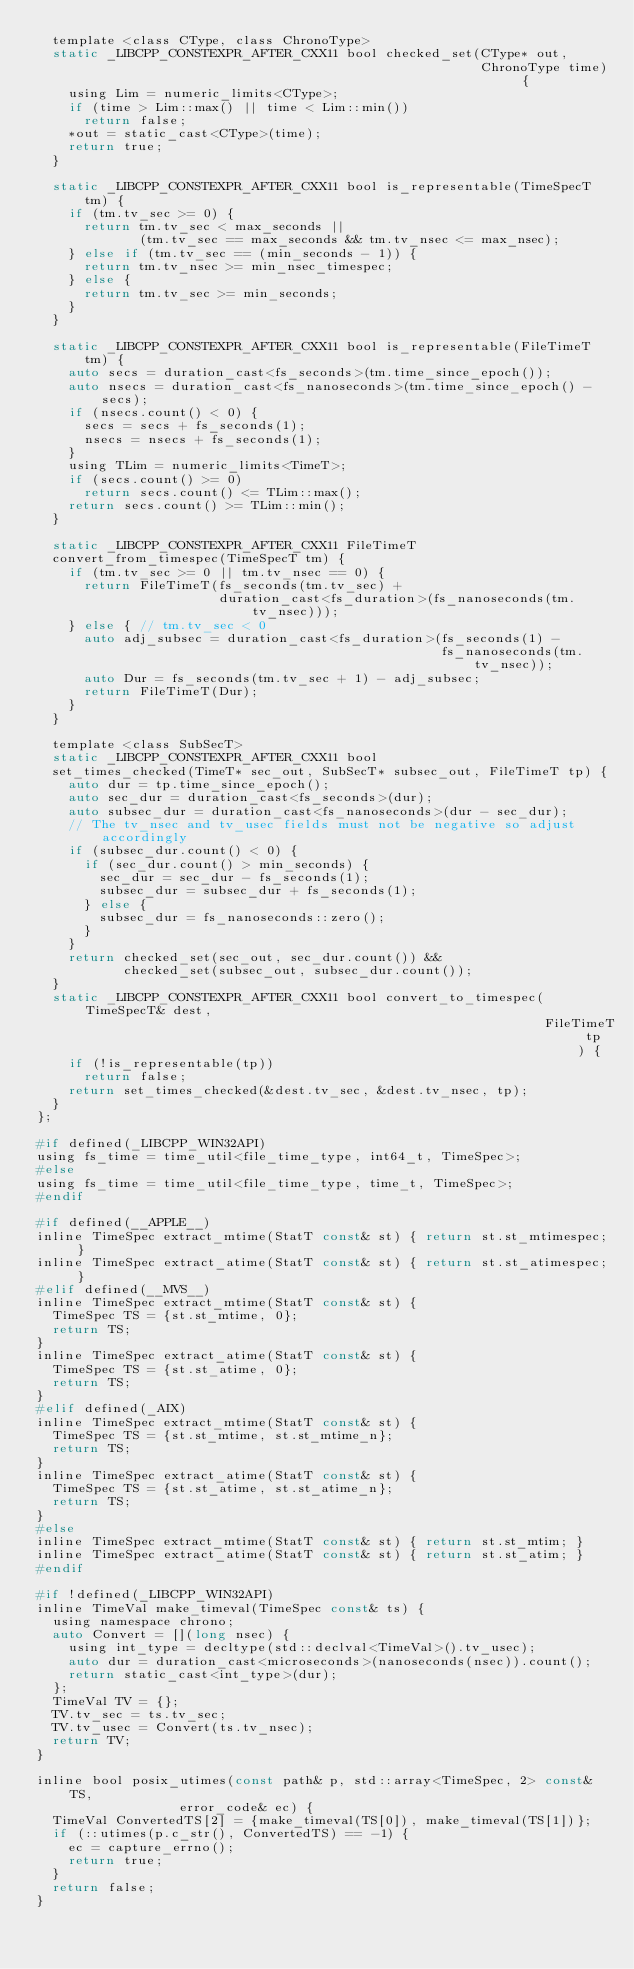Convert code to text. <code><loc_0><loc_0><loc_500><loc_500><_C_>  template <class CType, class ChronoType>
  static _LIBCPP_CONSTEXPR_AFTER_CXX11 bool checked_set(CType* out,
                                                        ChronoType time) {
    using Lim = numeric_limits<CType>;
    if (time > Lim::max() || time < Lim::min())
      return false;
    *out = static_cast<CType>(time);
    return true;
  }

  static _LIBCPP_CONSTEXPR_AFTER_CXX11 bool is_representable(TimeSpecT tm) {
    if (tm.tv_sec >= 0) {
      return tm.tv_sec < max_seconds ||
             (tm.tv_sec == max_seconds && tm.tv_nsec <= max_nsec);
    } else if (tm.tv_sec == (min_seconds - 1)) {
      return tm.tv_nsec >= min_nsec_timespec;
    } else {
      return tm.tv_sec >= min_seconds;
    }
  }

  static _LIBCPP_CONSTEXPR_AFTER_CXX11 bool is_representable(FileTimeT tm) {
    auto secs = duration_cast<fs_seconds>(tm.time_since_epoch());
    auto nsecs = duration_cast<fs_nanoseconds>(tm.time_since_epoch() - secs);
    if (nsecs.count() < 0) {
      secs = secs + fs_seconds(1);
      nsecs = nsecs + fs_seconds(1);
    }
    using TLim = numeric_limits<TimeT>;
    if (secs.count() >= 0)
      return secs.count() <= TLim::max();
    return secs.count() >= TLim::min();
  }

  static _LIBCPP_CONSTEXPR_AFTER_CXX11 FileTimeT
  convert_from_timespec(TimeSpecT tm) {
    if (tm.tv_sec >= 0 || tm.tv_nsec == 0) {
      return FileTimeT(fs_seconds(tm.tv_sec) +
                       duration_cast<fs_duration>(fs_nanoseconds(tm.tv_nsec)));
    } else { // tm.tv_sec < 0
      auto adj_subsec = duration_cast<fs_duration>(fs_seconds(1) -
                                                   fs_nanoseconds(tm.tv_nsec));
      auto Dur = fs_seconds(tm.tv_sec + 1) - adj_subsec;
      return FileTimeT(Dur);
    }
  }

  template <class SubSecT>
  static _LIBCPP_CONSTEXPR_AFTER_CXX11 bool
  set_times_checked(TimeT* sec_out, SubSecT* subsec_out, FileTimeT tp) {
    auto dur = tp.time_since_epoch();
    auto sec_dur = duration_cast<fs_seconds>(dur);
    auto subsec_dur = duration_cast<fs_nanoseconds>(dur - sec_dur);
    // The tv_nsec and tv_usec fields must not be negative so adjust accordingly
    if (subsec_dur.count() < 0) {
      if (sec_dur.count() > min_seconds) {
        sec_dur = sec_dur - fs_seconds(1);
        subsec_dur = subsec_dur + fs_seconds(1);
      } else {
        subsec_dur = fs_nanoseconds::zero();
      }
    }
    return checked_set(sec_out, sec_dur.count()) &&
           checked_set(subsec_out, subsec_dur.count());
  }
  static _LIBCPP_CONSTEXPR_AFTER_CXX11 bool convert_to_timespec(TimeSpecT& dest,
                                                                FileTimeT tp) {
    if (!is_representable(tp))
      return false;
    return set_times_checked(&dest.tv_sec, &dest.tv_nsec, tp);
  }
};

#if defined(_LIBCPP_WIN32API)
using fs_time = time_util<file_time_type, int64_t, TimeSpec>;
#else
using fs_time = time_util<file_time_type, time_t, TimeSpec>;
#endif

#if defined(__APPLE__)
inline TimeSpec extract_mtime(StatT const& st) { return st.st_mtimespec; }
inline TimeSpec extract_atime(StatT const& st) { return st.st_atimespec; }
#elif defined(__MVS__)
inline TimeSpec extract_mtime(StatT const& st) {
  TimeSpec TS = {st.st_mtime, 0};
  return TS;
}
inline TimeSpec extract_atime(StatT const& st) {
  TimeSpec TS = {st.st_atime, 0};
  return TS;
}
#elif defined(_AIX)
inline TimeSpec extract_mtime(StatT const& st) {
  TimeSpec TS = {st.st_mtime, st.st_mtime_n};
  return TS;
}
inline TimeSpec extract_atime(StatT const& st) {
  TimeSpec TS = {st.st_atime, st.st_atime_n};
  return TS;
}
#else
inline TimeSpec extract_mtime(StatT const& st) { return st.st_mtim; }
inline TimeSpec extract_atime(StatT const& st) { return st.st_atim; }
#endif

#if !defined(_LIBCPP_WIN32API)
inline TimeVal make_timeval(TimeSpec const& ts) {
  using namespace chrono;
  auto Convert = [](long nsec) {
    using int_type = decltype(std::declval<TimeVal>().tv_usec);
    auto dur = duration_cast<microseconds>(nanoseconds(nsec)).count();
    return static_cast<int_type>(dur);
  };
  TimeVal TV = {};
  TV.tv_sec = ts.tv_sec;
  TV.tv_usec = Convert(ts.tv_nsec);
  return TV;
}

inline bool posix_utimes(const path& p, std::array<TimeSpec, 2> const& TS,
                  error_code& ec) {
  TimeVal ConvertedTS[2] = {make_timeval(TS[0]), make_timeval(TS[1])};
  if (::utimes(p.c_str(), ConvertedTS) == -1) {
    ec = capture_errno();
    return true;
  }
  return false;
}
</code> 